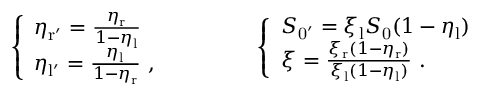Convert formula to latex. <formula><loc_0><loc_0><loc_500><loc_500>\left \{ \begin{array} { l l } { \eta _ { r ^ { \prime } } = \frac { \eta _ { r } } { 1 - \eta _ { l } } } \\ { \eta _ { l ^ { \prime } } = \frac { \eta _ { l } } { 1 - \eta _ { r } } \ , } \end{array} \quad \left \{ \begin{array} { l l } { S _ { 0 ^ { \prime } } = \xi _ { l } S _ { 0 } ( 1 - \eta _ { l } ) } \\ { \xi = \frac { \xi _ { r } ( 1 - \eta _ { r } ) } { \xi _ { l } ( 1 - \eta _ { l } ) } \ . } \end{array}</formula> 